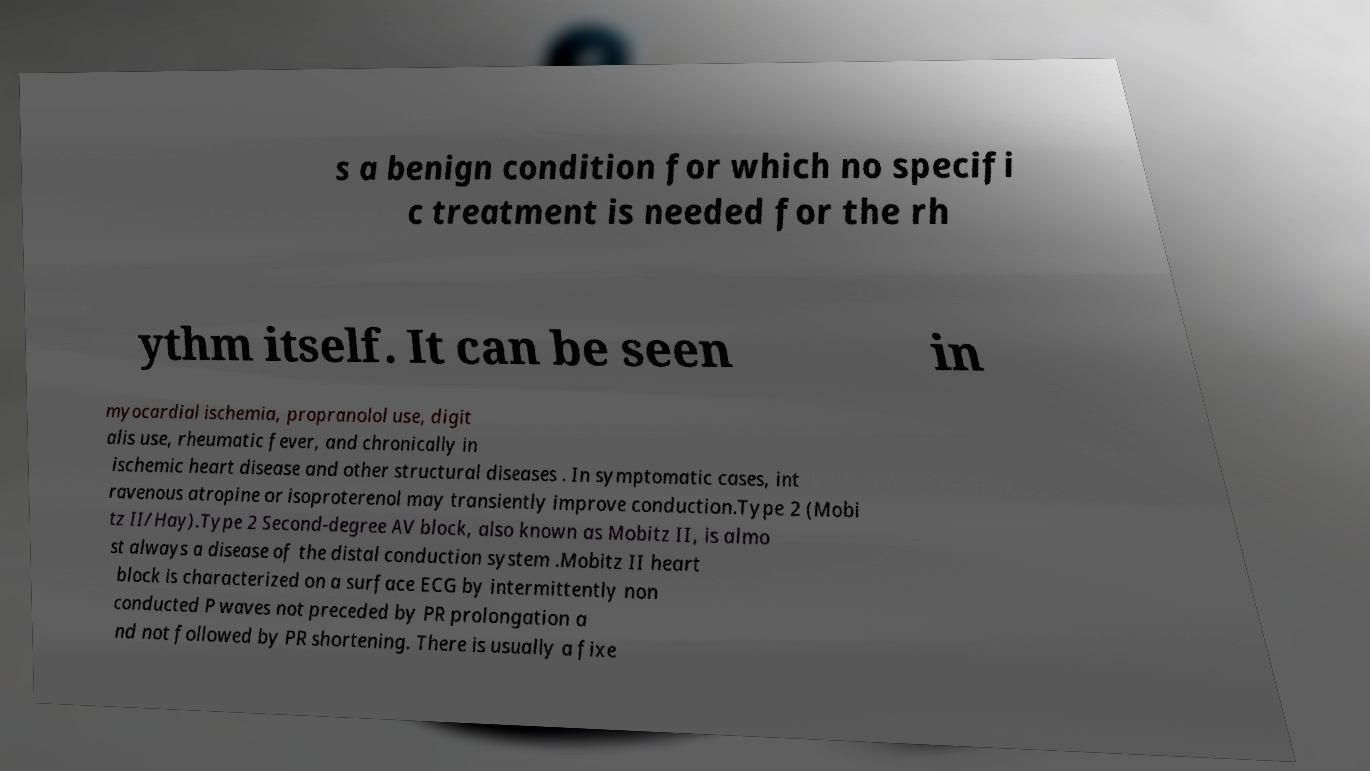Could you extract and type out the text from this image? s a benign condition for which no specifi c treatment is needed for the rh ythm itself. It can be seen in myocardial ischemia, propranolol use, digit alis use, rheumatic fever, and chronically in ischemic heart disease and other structural diseases . In symptomatic cases, int ravenous atropine or isoproterenol may transiently improve conduction.Type 2 (Mobi tz II/Hay).Type 2 Second-degree AV block, also known as Mobitz II, is almo st always a disease of the distal conduction system .Mobitz II heart block is characterized on a surface ECG by intermittently non conducted P waves not preceded by PR prolongation a nd not followed by PR shortening. There is usually a fixe 